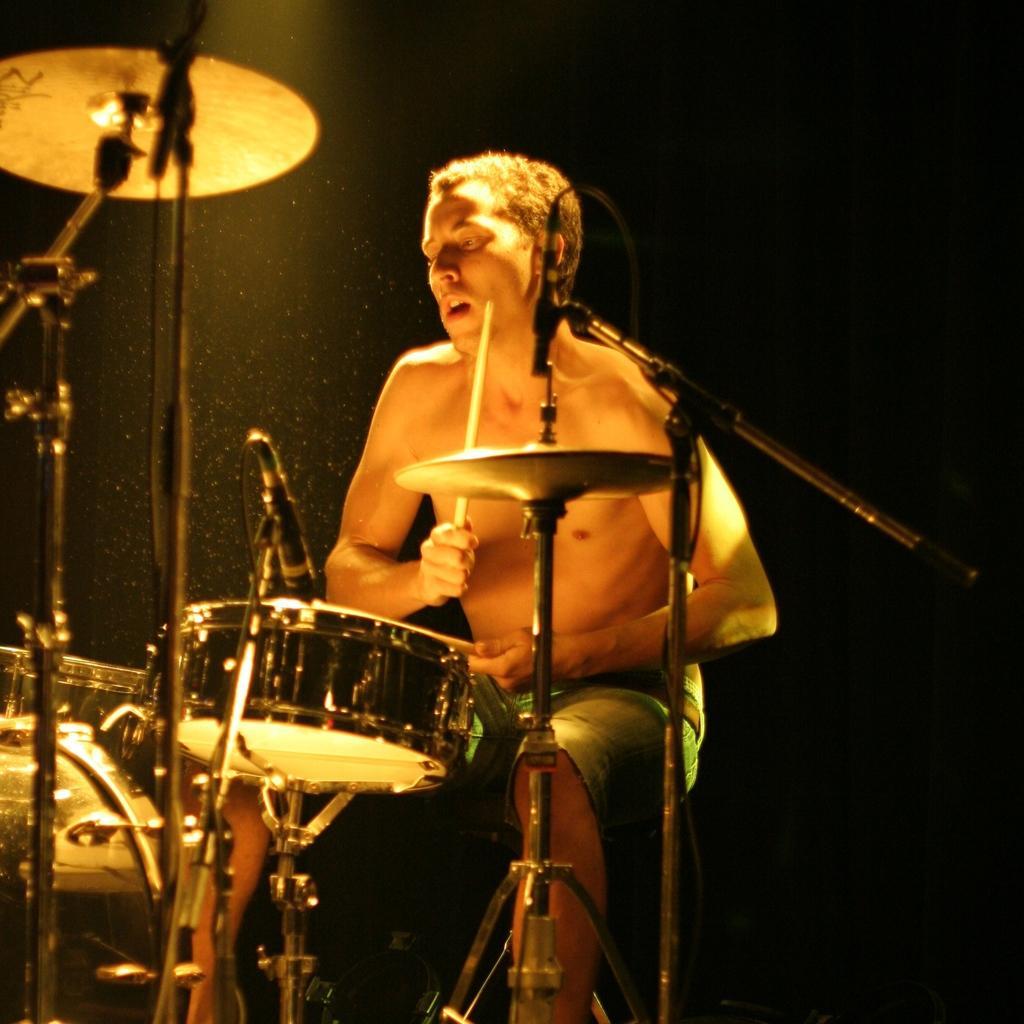Describe this image in one or two sentences. There is a man holding sticks in his hands in front of a drum set in the image. 